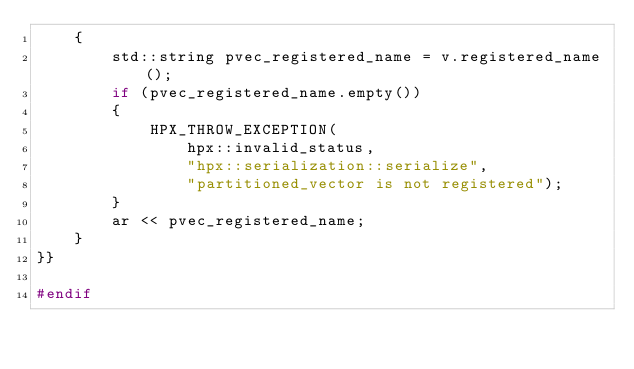<code> <loc_0><loc_0><loc_500><loc_500><_C++_>    {
        std::string pvec_registered_name = v.registered_name();
        if (pvec_registered_name.empty())
        {
            HPX_THROW_EXCEPTION(
                hpx::invalid_status,
                "hpx::serialization::serialize",
                "partitioned_vector is not registered");
        }
        ar << pvec_registered_name;
    }
}}

#endif
</code> 